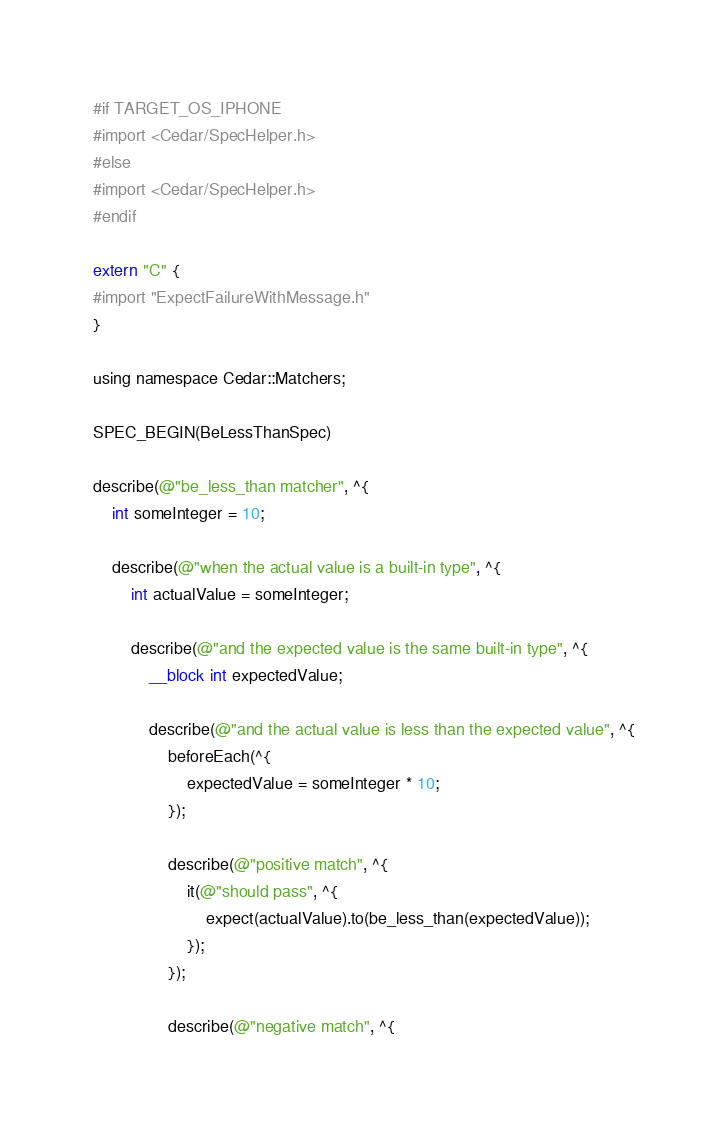Convert code to text. <code><loc_0><loc_0><loc_500><loc_500><_ObjectiveC_>#if TARGET_OS_IPHONE
#import <Cedar/SpecHelper.h>
#else
#import <Cedar/SpecHelper.h>
#endif

extern "C" {
#import "ExpectFailureWithMessage.h"
}

using namespace Cedar::Matchers;

SPEC_BEGIN(BeLessThanSpec)

describe(@"be_less_than matcher", ^{
    int someInteger = 10;

    describe(@"when the actual value is a built-in type", ^{
        int actualValue = someInteger;

        describe(@"and the expected value is the same built-in type", ^{
            __block int expectedValue;

            describe(@"and the actual value is less than the expected value", ^{
                beforeEach(^{
                    expectedValue = someInteger * 10;
                });

                describe(@"positive match", ^{
                    it(@"should pass", ^{
                        expect(actualValue).to(be_less_than(expectedValue));
                    });
                });

                describe(@"negative match", ^{</code> 